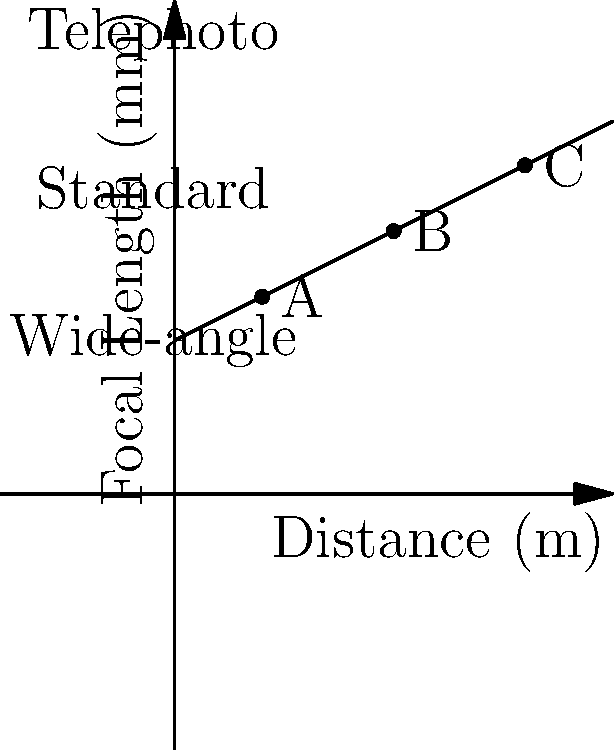As a paparazzi photographer, you're often faced with the challenge of capturing candid celebrity photos at various distances. The graph shows the relationship between distance and optimal focal length for clear, detailed shots. Points A, B, and C represent different shooting scenarios. Which point represents the ideal focal length for a discreet long-distance shot, and what type of lens would you likely use? To answer this question, let's analyze the graph and the information provided:

1. The x-axis represents the distance in meters, while the y-axis shows the focal length in millimeters.
2. The graph shows a positive linear relationship between distance and focal length.
3. There are three labeled regions on the y-axis:
   - Wide-angle: approximately 35-70mm
   - Standard: approximately 70-105mm
   - Telephoto: above 105mm
4. Points A, B, and C are marked on the graph:
   - Point A: (20m, 45mm)
   - Point B: (50m, 60mm)
   - Point C: (80m, 75mm)

5. For a discreet long-distance shot, we want the point that represents the greatest distance and longest focal length.

6. Point C is at the farthest distance (80m) and has the longest focal length (75mm) among the three points.

7. The focal length of 75mm falls within the "Standard" lens category, but it's close to the telephoto range.

Therefore, Point C represents the ideal focal length for a discreet long-distance shot, and you would likely use a standard zoom lens or a short telephoto lens for this scenario.
Answer: Point C; Standard zoom or short telephoto lens 